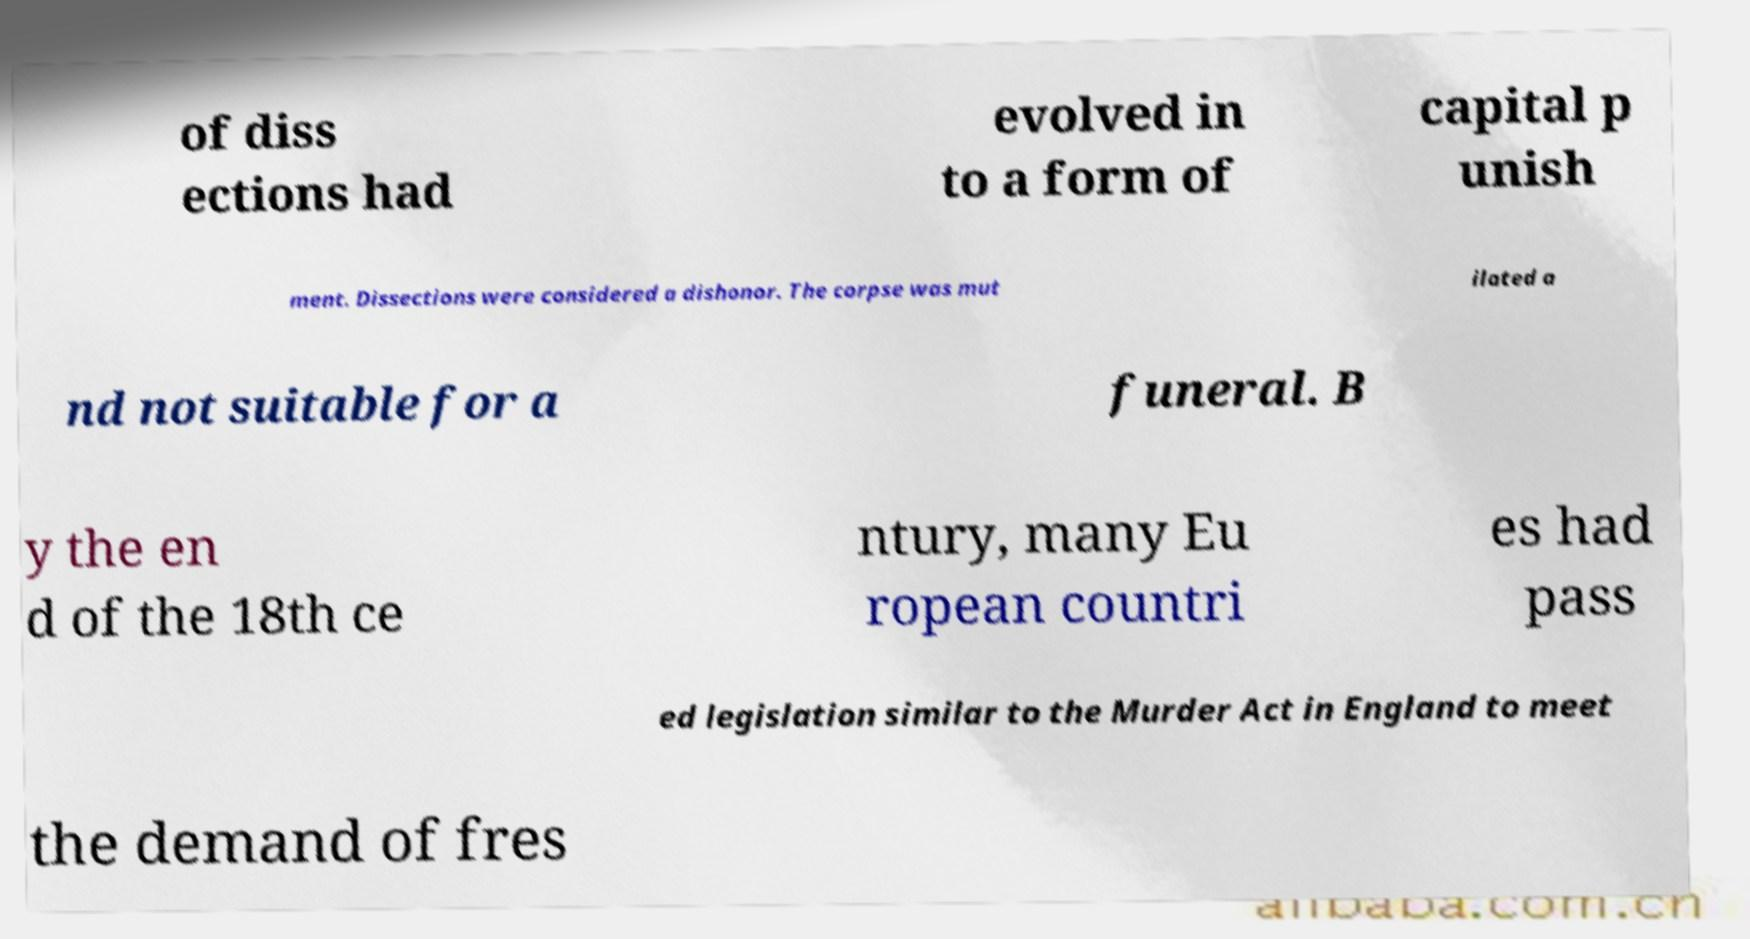There's text embedded in this image that I need extracted. Can you transcribe it verbatim? of diss ections had evolved in to a form of capital p unish ment. Dissections were considered a dishonor. The corpse was mut ilated a nd not suitable for a funeral. B y the en d of the 18th ce ntury, many Eu ropean countri es had pass ed legislation similar to the Murder Act in England to meet the demand of fres 